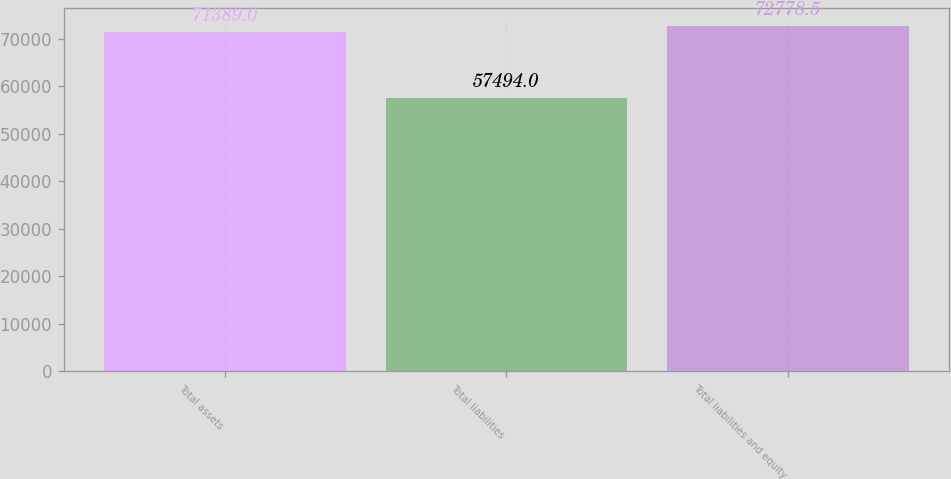<chart> <loc_0><loc_0><loc_500><loc_500><bar_chart><fcel>Total assets<fcel>Total liabilities<fcel>Total liabilities and equity<nl><fcel>71389<fcel>57494<fcel>72778.5<nl></chart> 